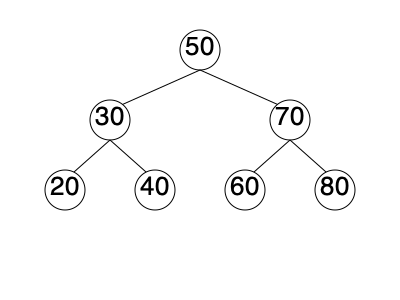Given the binary search tree shown above, implement a function to find the height of the tree without using any modern libraries or recursive algorithms. Assume each node contains only an integer value and pointers to left and right child nodes. What is the height of this tree? To find the height of the binary search tree without using recursion or modern libraries, we can implement an iterative approach using a stack data structure. Here's a step-by-step explanation:

1. Define a node structure with integer value and left and right child pointers.
2. Implement a stack structure to store nodes and their depths.
3. Initialize an empty stack and push the root node with depth 1.
4. Initialize max_height to 0.
5. While the stack is not empty:
   a. Pop a node and its depth from the stack.
   b. Update max_height if the current depth is greater.
   c. If the node has a right child, push it to the stack with depth + 1.
   d. If the node has a left child, push it to the stack with depth + 1.
6. After the loop, max_height will contain the height of the tree.

For the given tree:
- Level 1: 50 (root)
- Level 2: 30, 70
- Level 3: 20, 40, 60, 80

The maximum depth reached is 3, so the height of the tree is 3.

This approach avoids recursion and uses only basic data structures, aligning with the old-school computer scientist persona who prefers manual labor over modern libraries.
Answer: 3 